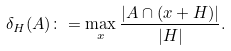Convert formula to latex. <formula><loc_0><loc_0><loc_500><loc_500>\delta _ { H } ( A ) \colon = \max _ { x } \frac { | A \cap ( x + H ) | } { | H | } .</formula> 